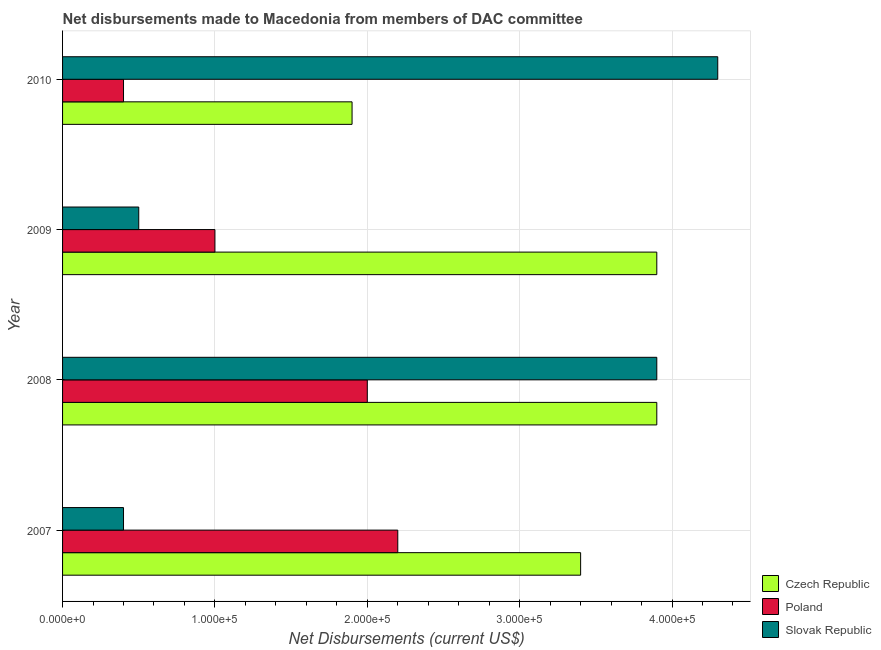How many different coloured bars are there?
Offer a very short reply. 3. Are the number of bars on each tick of the Y-axis equal?
Offer a very short reply. Yes. How many bars are there on the 4th tick from the top?
Offer a very short reply. 3. How many bars are there on the 3rd tick from the bottom?
Keep it short and to the point. 3. What is the label of the 1st group of bars from the top?
Your response must be concise. 2010. What is the net disbursements made by slovak republic in 2010?
Ensure brevity in your answer.  4.30e+05. Across all years, what is the maximum net disbursements made by slovak republic?
Provide a succinct answer. 4.30e+05. Across all years, what is the minimum net disbursements made by czech republic?
Provide a succinct answer. 1.90e+05. In which year was the net disbursements made by poland maximum?
Offer a very short reply. 2007. In which year was the net disbursements made by poland minimum?
Offer a very short reply. 2010. What is the total net disbursements made by czech republic in the graph?
Provide a succinct answer. 1.31e+06. What is the difference between the net disbursements made by poland in 2009 and that in 2010?
Ensure brevity in your answer.  6.00e+04. What is the difference between the net disbursements made by slovak republic in 2007 and the net disbursements made by poland in 2009?
Your answer should be compact. -6.00e+04. What is the average net disbursements made by czech republic per year?
Your answer should be very brief. 3.28e+05. In the year 2007, what is the difference between the net disbursements made by czech republic and net disbursements made by poland?
Give a very brief answer. 1.20e+05. In how many years, is the net disbursements made by czech republic greater than 180000 US$?
Give a very brief answer. 4. What is the ratio of the net disbursements made by slovak republic in 2007 to that in 2010?
Your answer should be very brief. 0.09. Is the net disbursements made by poland in 2008 less than that in 2010?
Keep it short and to the point. No. What is the difference between the highest and the lowest net disbursements made by poland?
Give a very brief answer. 1.80e+05. In how many years, is the net disbursements made by poland greater than the average net disbursements made by poland taken over all years?
Make the answer very short. 2. What does the 2nd bar from the top in 2008 represents?
Offer a very short reply. Poland. What does the 3rd bar from the bottom in 2009 represents?
Make the answer very short. Slovak Republic. How many years are there in the graph?
Offer a very short reply. 4. What is the difference between two consecutive major ticks on the X-axis?
Make the answer very short. 1.00e+05. Does the graph contain any zero values?
Provide a short and direct response. No. What is the title of the graph?
Offer a terse response. Net disbursements made to Macedonia from members of DAC committee. What is the label or title of the X-axis?
Make the answer very short. Net Disbursements (current US$). What is the label or title of the Y-axis?
Offer a very short reply. Year. What is the Net Disbursements (current US$) of Poland in 2007?
Give a very brief answer. 2.20e+05. What is the Net Disbursements (current US$) of Slovak Republic in 2007?
Provide a succinct answer. 4.00e+04. What is the Net Disbursements (current US$) in Slovak Republic in 2009?
Your answer should be very brief. 5.00e+04. What is the Net Disbursements (current US$) of Czech Republic in 2010?
Offer a terse response. 1.90e+05. What is the Net Disbursements (current US$) in Slovak Republic in 2010?
Your answer should be very brief. 4.30e+05. Across all years, what is the maximum Net Disbursements (current US$) in Czech Republic?
Offer a terse response. 3.90e+05. Across all years, what is the minimum Net Disbursements (current US$) of Czech Republic?
Your answer should be compact. 1.90e+05. Across all years, what is the minimum Net Disbursements (current US$) in Slovak Republic?
Keep it short and to the point. 4.00e+04. What is the total Net Disbursements (current US$) of Czech Republic in the graph?
Your answer should be compact. 1.31e+06. What is the total Net Disbursements (current US$) of Poland in the graph?
Provide a short and direct response. 5.60e+05. What is the total Net Disbursements (current US$) in Slovak Republic in the graph?
Provide a short and direct response. 9.10e+05. What is the difference between the Net Disbursements (current US$) of Czech Republic in 2007 and that in 2008?
Keep it short and to the point. -5.00e+04. What is the difference between the Net Disbursements (current US$) of Poland in 2007 and that in 2008?
Keep it short and to the point. 2.00e+04. What is the difference between the Net Disbursements (current US$) of Slovak Republic in 2007 and that in 2008?
Make the answer very short. -3.50e+05. What is the difference between the Net Disbursements (current US$) of Czech Republic in 2007 and that in 2009?
Ensure brevity in your answer.  -5.00e+04. What is the difference between the Net Disbursements (current US$) of Slovak Republic in 2007 and that in 2009?
Your answer should be compact. -10000. What is the difference between the Net Disbursements (current US$) of Poland in 2007 and that in 2010?
Offer a very short reply. 1.80e+05. What is the difference between the Net Disbursements (current US$) of Slovak Republic in 2007 and that in 2010?
Your response must be concise. -3.90e+05. What is the difference between the Net Disbursements (current US$) in Czech Republic in 2008 and that in 2009?
Ensure brevity in your answer.  0. What is the difference between the Net Disbursements (current US$) of Poland in 2008 and that in 2010?
Provide a short and direct response. 1.60e+05. What is the difference between the Net Disbursements (current US$) of Slovak Republic in 2008 and that in 2010?
Offer a very short reply. -4.00e+04. What is the difference between the Net Disbursements (current US$) of Poland in 2009 and that in 2010?
Keep it short and to the point. 6.00e+04. What is the difference between the Net Disbursements (current US$) in Slovak Republic in 2009 and that in 2010?
Offer a very short reply. -3.80e+05. What is the difference between the Net Disbursements (current US$) of Poland in 2007 and the Net Disbursements (current US$) of Slovak Republic in 2008?
Make the answer very short. -1.70e+05. What is the difference between the Net Disbursements (current US$) in Czech Republic in 2007 and the Net Disbursements (current US$) in Poland in 2009?
Offer a very short reply. 2.40e+05. What is the difference between the Net Disbursements (current US$) in Czech Republic in 2007 and the Net Disbursements (current US$) in Slovak Republic in 2009?
Make the answer very short. 2.90e+05. What is the difference between the Net Disbursements (current US$) in Czech Republic in 2007 and the Net Disbursements (current US$) in Poland in 2010?
Your answer should be compact. 3.00e+05. What is the difference between the Net Disbursements (current US$) of Poland in 2007 and the Net Disbursements (current US$) of Slovak Republic in 2010?
Ensure brevity in your answer.  -2.10e+05. What is the difference between the Net Disbursements (current US$) of Czech Republic in 2008 and the Net Disbursements (current US$) of Poland in 2009?
Provide a succinct answer. 2.90e+05. What is the difference between the Net Disbursements (current US$) in Czech Republic in 2008 and the Net Disbursements (current US$) in Slovak Republic in 2010?
Offer a terse response. -4.00e+04. What is the difference between the Net Disbursements (current US$) of Czech Republic in 2009 and the Net Disbursements (current US$) of Slovak Republic in 2010?
Offer a terse response. -4.00e+04. What is the difference between the Net Disbursements (current US$) of Poland in 2009 and the Net Disbursements (current US$) of Slovak Republic in 2010?
Provide a succinct answer. -3.30e+05. What is the average Net Disbursements (current US$) of Czech Republic per year?
Offer a terse response. 3.28e+05. What is the average Net Disbursements (current US$) of Poland per year?
Offer a terse response. 1.40e+05. What is the average Net Disbursements (current US$) in Slovak Republic per year?
Provide a succinct answer. 2.28e+05. In the year 2007, what is the difference between the Net Disbursements (current US$) of Czech Republic and Net Disbursements (current US$) of Slovak Republic?
Your response must be concise. 3.00e+05. In the year 2007, what is the difference between the Net Disbursements (current US$) in Poland and Net Disbursements (current US$) in Slovak Republic?
Offer a terse response. 1.80e+05. In the year 2008, what is the difference between the Net Disbursements (current US$) of Czech Republic and Net Disbursements (current US$) of Poland?
Offer a terse response. 1.90e+05. In the year 2008, what is the difference between the Net Disbursements (current US$) in Czech Republic and Net Disbursements (current US$) in Slovak Republic?
Make the answer very short. 0. In the year 2009, what is the difference between the Net Disbursements (current US$) in Czech Republic and Net Disbursements (current US$) in Poland?
Your answer should be very brief. 2.90e+05. In the year 2010, what is the difference between the Net Disbursements (current US$) in Czech Republic and Net Disbursements (current US$) in Poland?
Your response must be concise. 1.50e+05. In the year 2010, what is the difference between the Net Disbursements (current US$) in Poland and Net Disbursements (current US$) in Slovak Republic?
Provide a short and direct response. -3.90e+05. What is the ratio of the Net Disbursements (current US$) in Czech Republic in 2007 to that in 2008?
Provide a succinct answer. 0.87. What is the ratio of the Net Disbursements (current US$) of Poland in 2007 to that in 2008?
Ensure brevity in your answer.  1.1. What is the ratio of the Net Disbursements (current US$) of Slovak Republic in 2007 to that in 2008?
Provide a succinct answer. 0.1. What is the ratio of the Net Disbursements (current US$) of Czech Republic in 2007 to that in 2009?
Keep it short and to the point. 0.87. What is the ratio of the Net Disbursements (current US$) of Poland in 2007 to that in 2009?
Offer a very short reply. 2.2. What is the ratio of the Net Disbursements (current US$) of Czech Republic in 2007 to that in 2010?
Offer a terse response. 1.79. What is the ratio of the Net Disbursements (current US$) in Slovak Republic in 2007 to that in 2010?
Ensure brevity in your answer.  0.09. What is the ratio of the Net Disbursements (current US$) in Czech Republic in 2008 to that in 2009?
Offer a terse response. 1. What is the ratio of the Net Disbursements (current US$) of Czech Republic in 2008 to that in 2010?
Keep it short and to the point. 2.05. What is the ratio of the Net Disbursements (current US$) of Slovak Republic in 2008 to that in 2010?
Your answer should be compact. 0.91. What is the ratio of the Net Disbursements (current US$) in Czech Republic in 2009 to that in 2010?
Your response must be concise. 2.05. What is the ratio of the Net Disbursements (current US$) in Poland in 2009 to that in 2010?
Ensure brevity in your answer.  2.5. What is the ratio of the Net Disbursements (current US$) in Slovak Republic in 2009 to that in 2010?
Give a very brief answer. 0.12. What is the difference between the highest and the second highest Net Disbursements (current US$) in Czech Republic?
Ensure brevity in your answer.  0. What is the difference between the highest and the second highest Net Disbursements (current US$) in Poland?
Offer a terse response. 2.00e+04. What is the difference between the highest and the lowest Net Disbursements (current US$) of Slovak Republic?
Your response must be concise. 3.90e+05. 